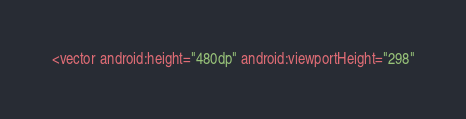Convert code to text. <code><loc_0><loc_0><loc_500><loc_500><_XML_><vector android:height="480dp" android:viewportHeight="298"</code> 